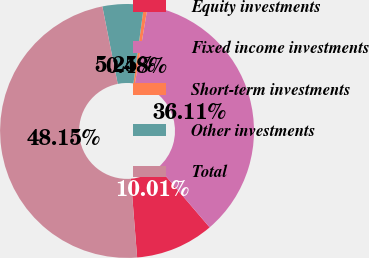Convert chart to OTSL. <chart><loc_0><loc_0><loc_500><loc_500><pie_chart><fcel>Equity investments<fcel>Fixed income investments<fcel>Short-term investments<fcel>Other investments<fcel>Total<nl><fcel>10.01%<fcel>36.11%<fcel>0.48%<fcel>5.25%<fcel>48.15%<nl></chart> 